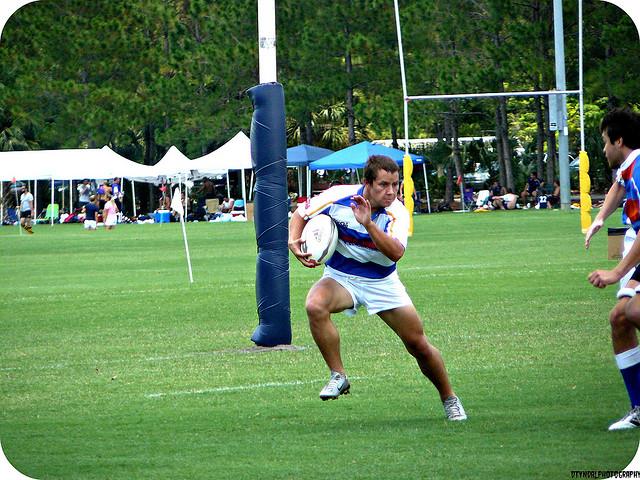Could this be rugby?
Short answer required. Yes. What sport is being played?
Concise answer only. Rugby. Is the man with the ball jumping?
Be succinct. No. 